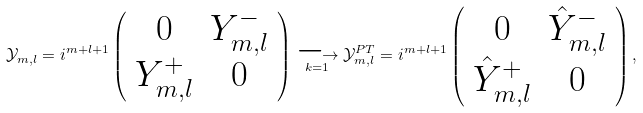<formula> <loc_0><loc_0><loc_500><loc_500>\mathcal { Y } _ { m , l } = i ^ { m + l + 1 } \left ( \begin{array} { c c } 0 & Y ^ { - } _ { m , l } \\ Y ^ { + } _ { m , l } & 0 \end{array} \right ) \underset { k = 1 } { \longrightarrow } \mathcal { Y } _ { m , l } ^ { P T } = i ^ { m + l + 1 } \left ( \begin{array} { c c } 0 & \hat { Y } ^ { - } _ { m , l } \\ \hat { Y } ^ { + } _ { m , l } & 0 \end{array} \right ) ,</formula> 